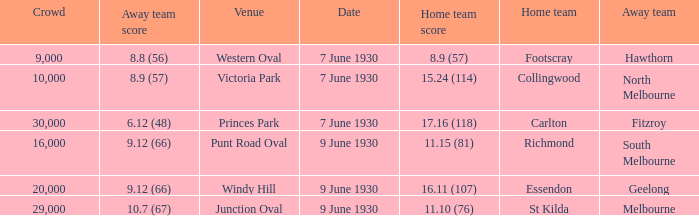What is the average crowd to watch Hawthorn as the away team? 9000.0. 